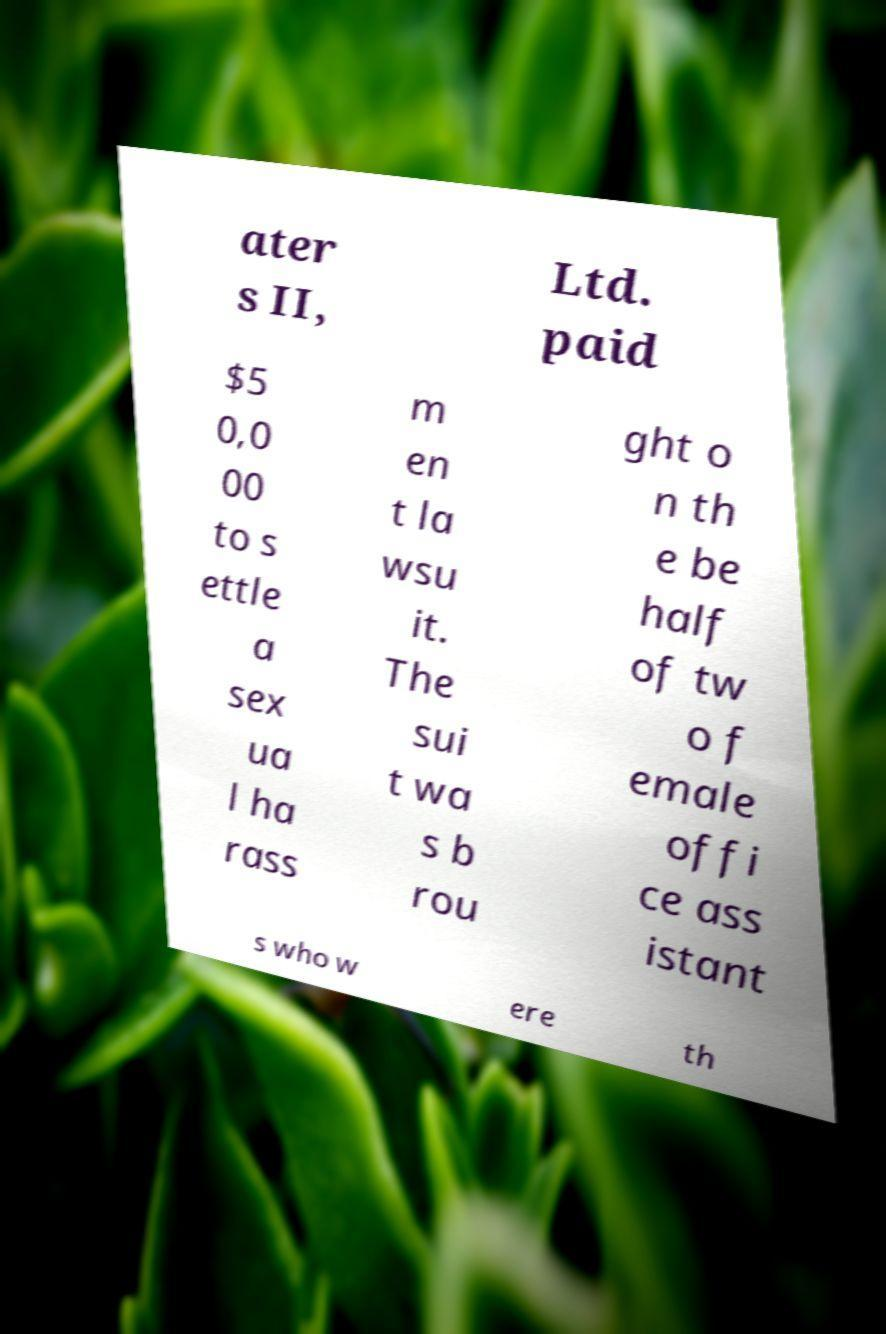Can you read and provide the text displayed in the image?This photo seems to have some interesting text. Can you extract and type it out for me? ater s II, Ltd. paid $5 0,0 00 to s ettle a sex ua l ha rass m en t la wsu it. The sui t wa s b rou ght o n th e be half of tw o f emale offi ce ass istant s who w ere th 